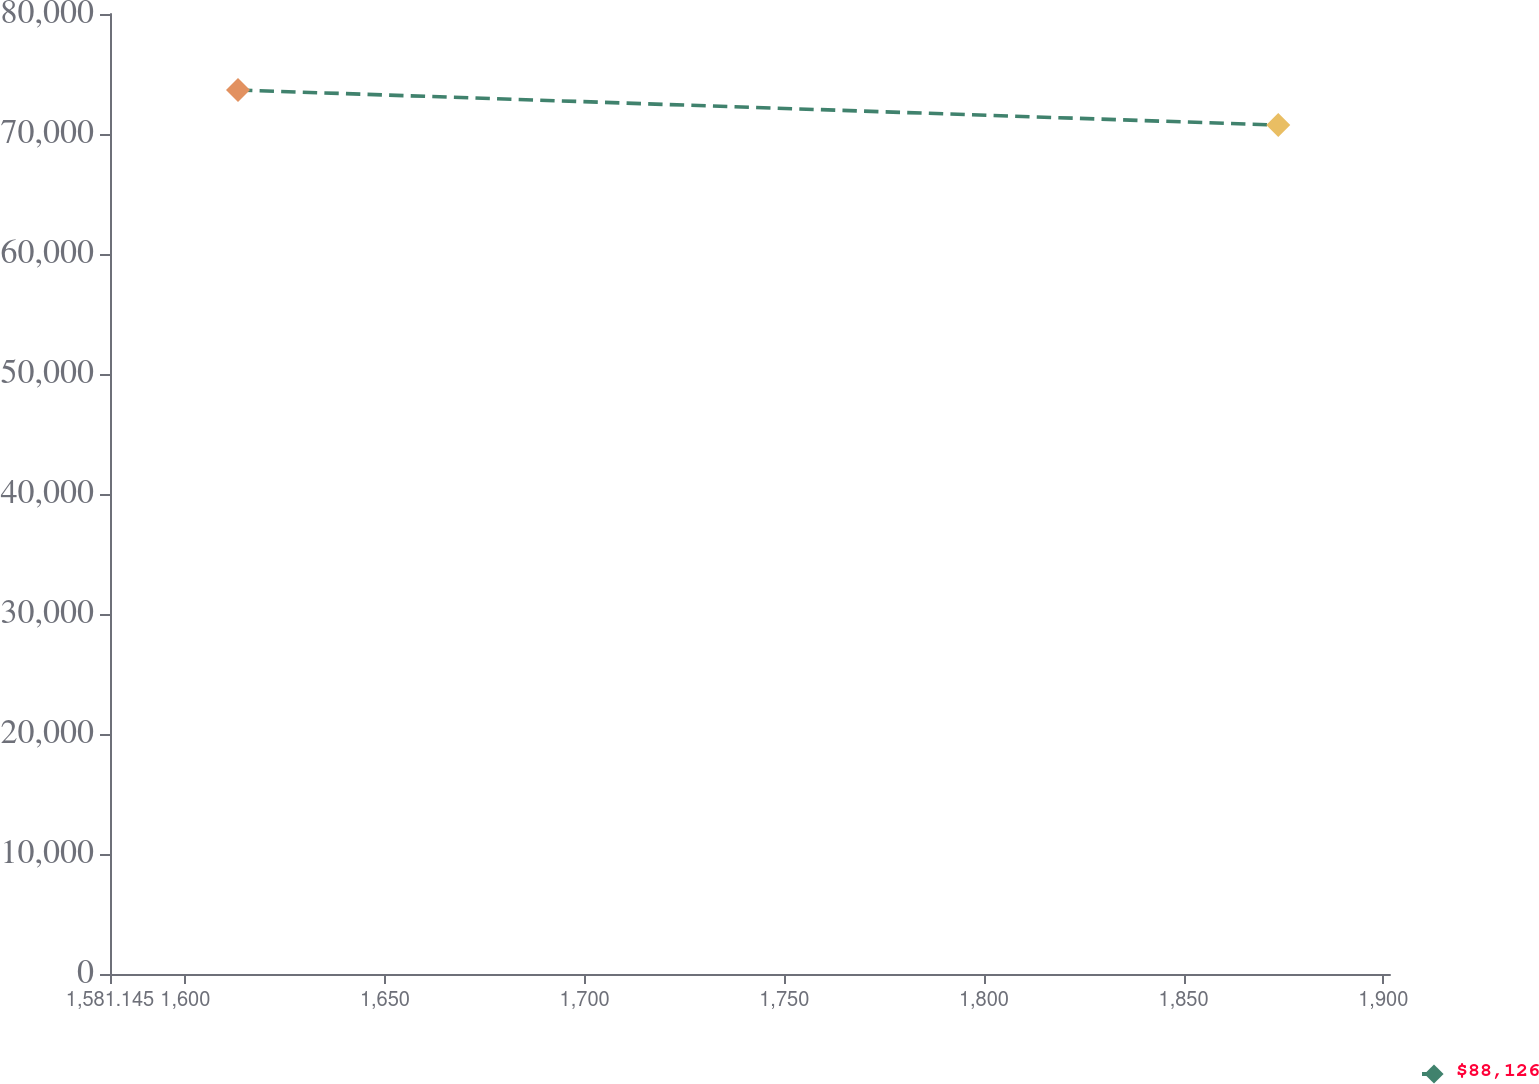Convert chart. <chart><loc_0><loc_0><loc_500><loc_500><line_chart><ecel><fcel>$88,126<nl><fcel>1613.2<fcel>73665.4<nl><fcel>1873.71<fcel>70741.7<nl><fcel>1903.73<fcel>78057.6<nl><fcel>1933.75<fcel>62283.7<nl></chart> 